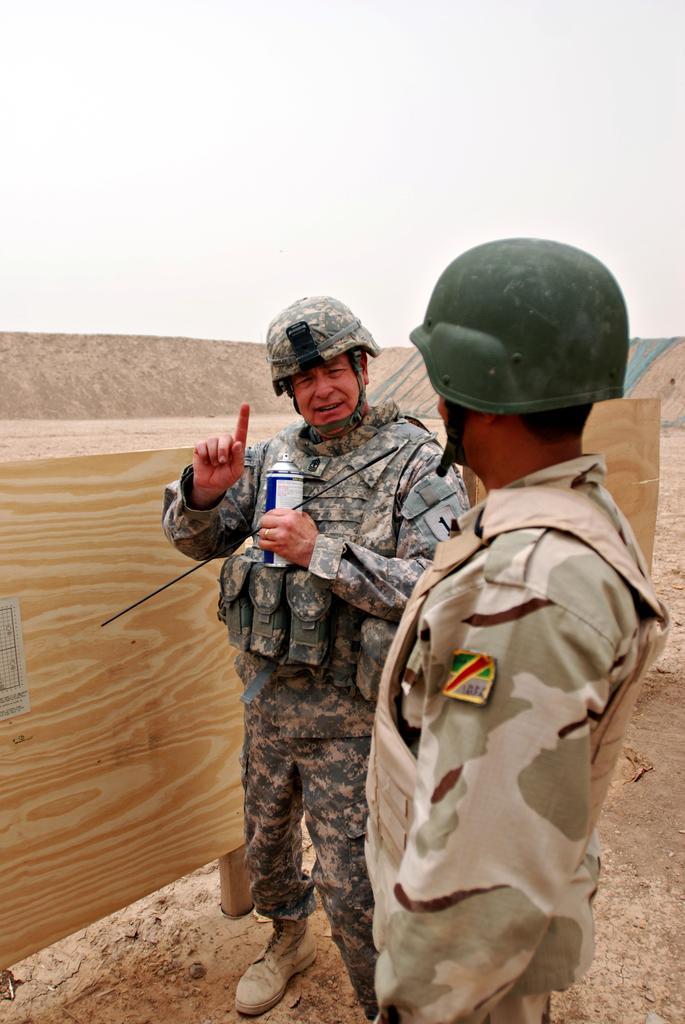Please provide a concise description of this image. In this image in the middle there is a man, he wears a shirt, trouser, shoes, helmet. On the right there is a man, he wears a shirt, trouser, helmet. In the background there is a board, land and sky. 